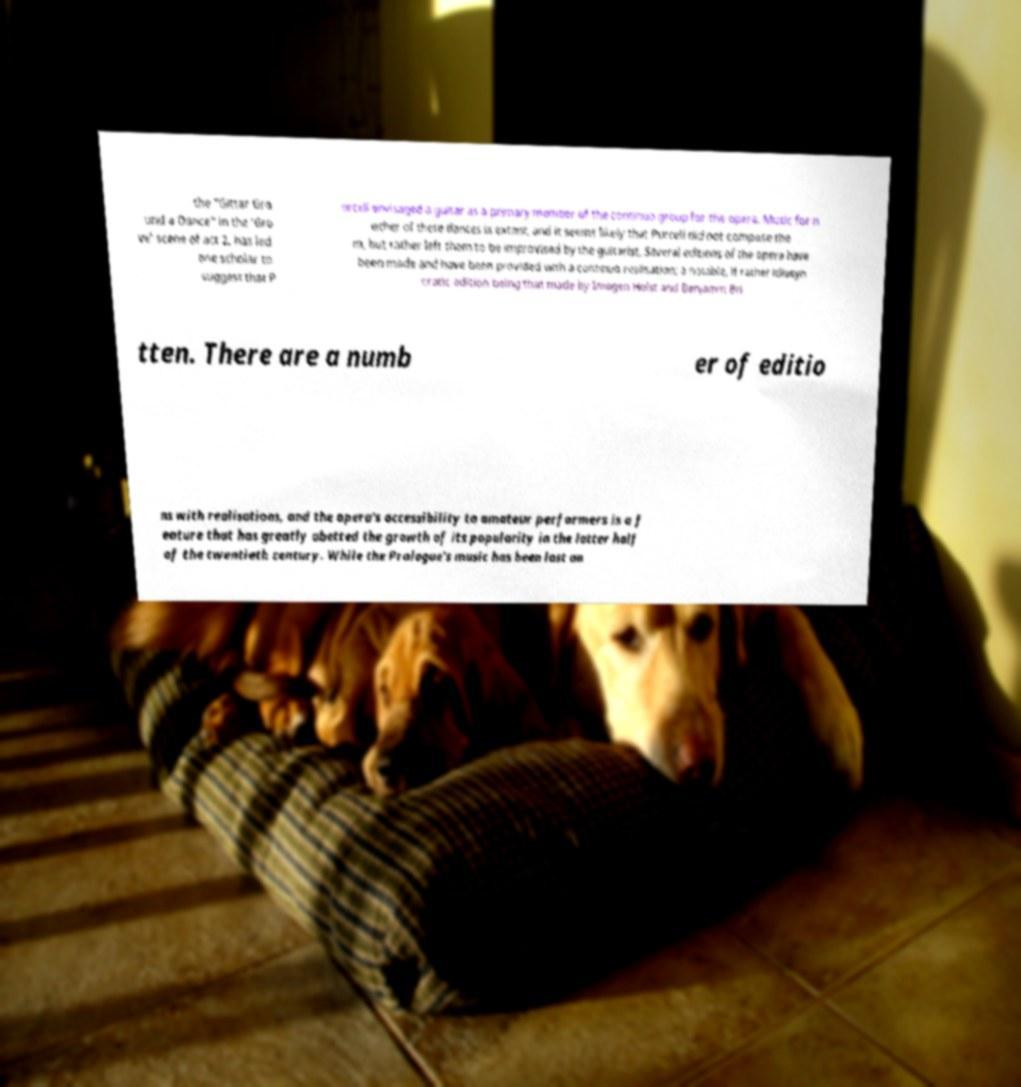Please identify and transcribe the text found in this image. the "Gittar Gro und a Dance" in the 'Gro ve' scene of act 2, has led one scholar to suggest that P urcell envisaged a guitar as a primary member of the continuo group for the opera. Music for n either of these dances is extant, and it seems likely that Purcell did not compose the m, but rather left them to be improvised by the guitarist. Several editions of the opera have been made and have been provided with a continuo realisation; a notable, if rather idiosyn cratic edition being that made by Imogen Holst and Benjamin Bri tten. There are a numb er of editio ns with realisations, and the opera's accessibility to amateur performers is a f eature that has greatly abetted the growth of its popularity in the latter half of the twentieth century. While the Prologue's music has been lost an 